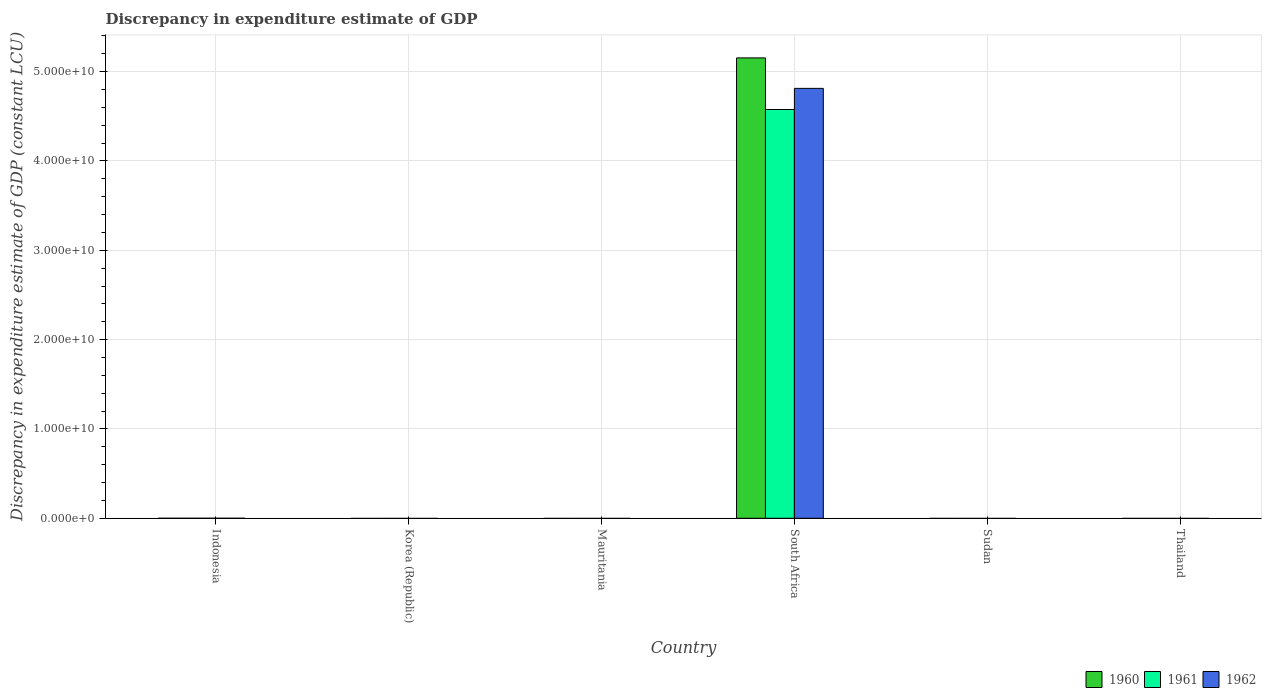Are the number of bars on each tick of the X-axis equal?
Offer a terse response. No. How many bars are there on the 4th tick from the left?
Provide a succinct answer. 3. How many bars are there on the 6th tick from the right?
Offer a very short reply. 0. What is the label of the 4th group of bars from the left?
Offer a terse response. South Africa. Across all countries, what is the maximum discrepancy in expenditure estimate of GDP in 1962?
Give a very brief answer. 4.81e+1. Across all countries, what is the minimum discrepancy in expenditure estimate of GDP in 1961?
Your response must be concise. 0. In which country was the discrepancy in expenditure estimate of GDP in 1960 maximum?
Your response must be concise. South Africa. What is the total discrepancy in expenditure estimate of GDP in 1961 in the graph?
Make the answer very short. 4.58e+1. What is the difference between the discrepancy in expenditure estimate of GDP in 1962 in Mauritania and the discrepancy in expenditure estimate of GDP in 1961 in Korea (Republic)?
Make the answer very short. 0. What is the average discrepancy in expenditure estimate of GDP in 1962 per country?
Offer a terse response. 8.02e+09. What is the difference between the discrepancy in expenditure estimate of GDP of/in 1960 and discrepancy in expenditure estimate of GDP of/in 1962 in South Africa?
Provide a succinct answer. 3.41e+09. What is the difference between the highest and the lowest discrepancy in expenditure estimate of GDP in 1962?
Offer a terse response. 4.81e+1. How many countries are there in the graph?
Provide a succinct answer. 6. Does the graph contain grids?
Give a very brief answer. Yes. How many legend labels are there?
Keep it short and to the point. 3. What is the title of the graph?
Offer a very short reply. Discrepancy in expenditure estimate of GDP. Does "2001" appear as one of the legend labels in the graph?
Give a very brief answer. No. What is the label or title of the X-axis?
Your answer should be very brief. Country. What is the label or title of the Y-axis?
Make the answer very short. Discrepancy in expenditure estimate of GDP (constant LCU). What is the Discrepancy in expenditure estimate of GDP (constant LCU) of 1960 in Indonesia?
Ensure brevity in your answer.  0. What is the Discrepancy in expenditure estimate of GDP (constant LCU) in 1962 in Indonesia?
Offer a terse response. 0. What is the Discrepancy in expenditure estimate of GDP (constant LCU) of 1961 in Korea (Republic)?
Offer a very short reply. 0. What is the Discrepancy in expenditure estimate of GDP (constant LCU) in 1962 in Korea (Republic)?
Ensure brevity in your answer.  0. What is the Discrepancy in expenditure estimate of GDP (constant LCU) of 1961 in Mauritania?
Keep it short and to the point. 0. What is the Discrepancy in expenditure estimate of GDP (constant LCU) of 1960 in South Africa?
Your response must be concise. 5.15e+1. What is the Discrepancy in expenditure estimate of GDP (constant LCU) in 1961 in South Africa?
Provide a short and direct response. 4.58e+1. What is the Discrepancy in expenditure estimate of GDP (constant LCU) of 1962 in South Africa?
Your answer should be very brief. 4.81e+1. What is the Discrepancy in expenditure estimate of GDP (constant LCU) in 1962 in Sudan?
Give a very brief answer. 0. What is the Discrepancy in expenditure estimate of GDP (constant LCU) in 1961 in Thailand?
Provide a succinct answer. 0. What is the Discrepancy in expenditure estimate of GDP (constant LCU) of 1962 in Thailand?
Make the answer very short. 0. Across all countries, what is the maximum Discrepancy in expenditure estimate of GDP (constant LCU) in 1960?
Offer a terse response. 5.15e+1. Across all countries, what is the maximum Discrepancy in expenditure estimate of GDP (constant LCU) in 1961?
Ensure brevity in your answer.  4.58e+1. Across all countries, what is the maximum Discrepancy in expenditure estimate of GDP (constant LCU) of 1962?
Your answer should be very brief. 4.81e+1. Across all countries, what is the minimum Discrepancy in expenditure estimate of GDP (constant LCU) in 1961?
Ensure brevity in your answer.  0. Across all countries, what is the minimum Discrepancy in expenditure estimate of GDP (constant LCU) in 1962?
Provide a succinct answer. 0. What is the total Discrepancy in expenditure estimate of GDP (constant LCU) of 1960 in the graph?
Make the answer very short. 5.15e+1. What is the total Discrepancy in expenditure estimate of GDP (constant LCU) in 1961 in the graph?
Offer a very short reply. 4.58e+1. What is the total Discrepancy in expenditure estimate of GDP (constant LCU) of 1962 in the graph?
Make the answer very short. 4.81e+1. What is the average Discrepancy in expenditure estimate of GDP (constant LCU) of 1960 per country?
Make the answer very short. 8.59e+09. What is the average Discrepancy in expenditure estimate of GDP (constant LCU) of 1961 per country?
Offer a terse response. 7.63e+09. What is the average Discrepancy in expenditure estimate of GDP (constant LCU) in 1962 per country?
Give a very brief answer. 8.02e+09. What is the difference between the Discrepancy in expenditure estimate of GDP (constant LCU) in 1960 and Discrepancy in expenditure estimate of GDP (constant LCU) in 1961 in South Africa?
Ensure brevity in your answer.  5.78e+09. What is the difference between the Discrepancy in expenditure estimate of GDP (constant LCU) of 1960 and Discrepancy in expenditure estimate of GDP (constant LCU) of 1962 in South Africa?
Keep it short and to the point. 3.41e+09. What is the difference between the Discrepancy in expenditure estimate of GDP (constant LCU) of 1961 and Discrepancy in expenditure estimate of GDP (constant LCU) of 1962 in South Africa?
Offer a terse response. -2.37e+09. What is the difference between the highest and the lowest Discrepancy in expenditure estimate of GDP (constant LCU) in 1960?
Make the answer very short. 5.15e+1. What is the difference between the highest and the lowest Discrepancy in expenditure estimate of GDP (constant LCU) in 1961?
Keep it short and to the point. 4.58e+1. What is the difference between the highest and the lowest Discrepancy in expenditure estimate of GDP (constant LCU) in 1962?
Give a very brief answer. 4.81e+1. 